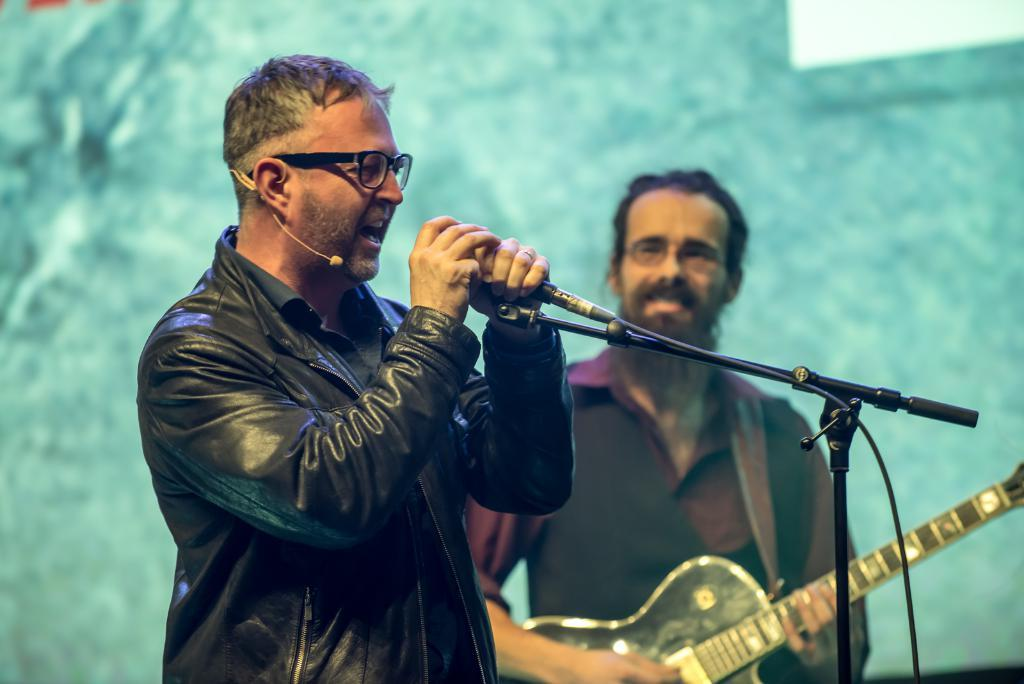How many people are in the image? There are two persons in the image. What are the two persons holding? One person is holding a microphone, and the other person is holding a guitar. What type of scarf is being used to improve the acoustics in the image? There is no scarf present in the image, and no mention of improving acoustics. 